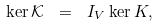Convert formula to latex. <formula><loc_0><loc_0><loc_500><loc_500>\ker \mathcal { K } \ = \ I _ { V } \ker K ,</formula> 